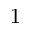Convert formula to latex. <formula><loc_0><loc_0><loc_500><loc_500>1</formula> 